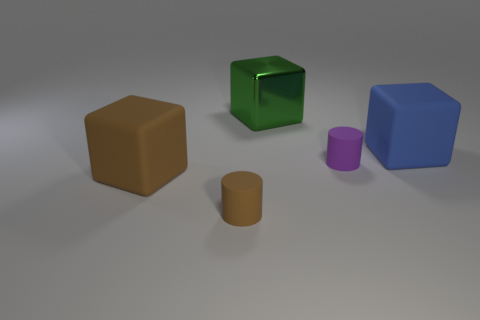How does the lighting affect the appearance of the objects? The lighting in the image casts soft shadows and highlights on the objects, giving a sense of depth and dimension. It accentuates the reflective properties of the shiny green cube while creating a softer look on the matte surfaces of the other objects. The lighting helps to distinguish the textures and contours of each shape. 